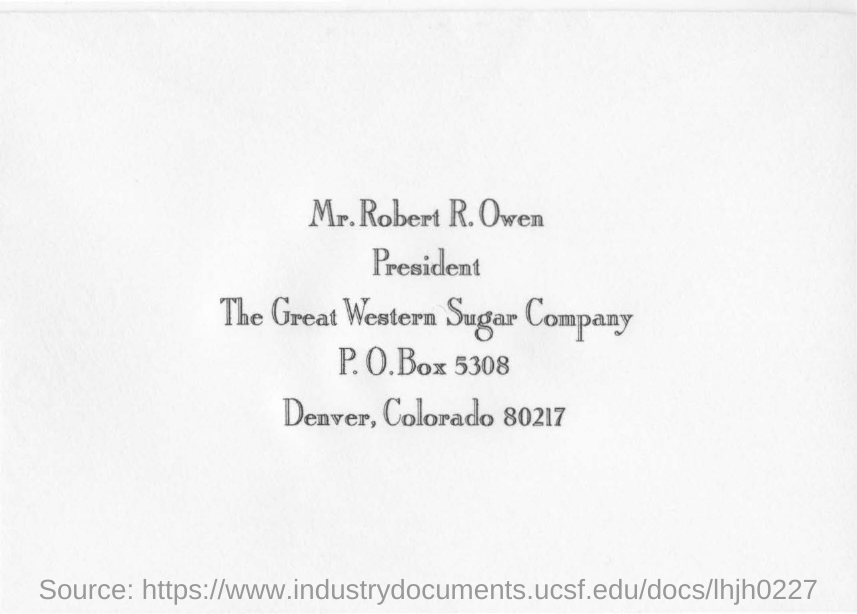What is the P. O.Box number in the document?
Make the answer very short. 5308. Where is the Great Western Sugar Company located?
Your response must be concise. Deaver, Colorado. 